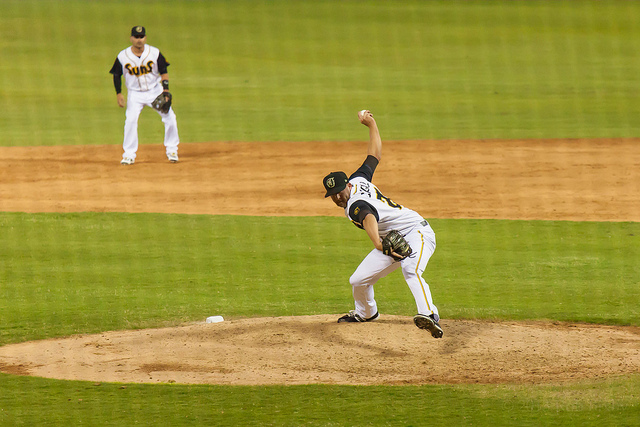Please transcribe the text information in this image. suns 